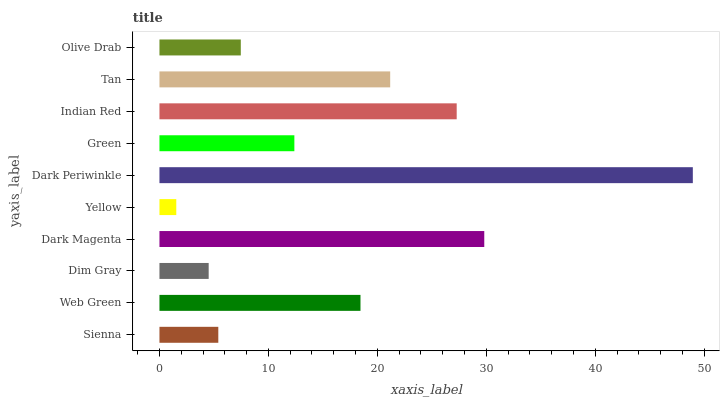Is Yellow the minimum?
Answer yes or no. Yes. Is Dark Periwinkle the maximum?
Answer yes or no. Yes. Is Web Green the minimum?
Answer yes or no. No. Is Web Green the maximum?
Answer yes or no. No. Is Web Green greater than Sienna?
Answer yes or no. Yes. Is Sienna less than Web Green?
Answer yes or no. Yes. Is Sienna greater than Web Green?
Answer yes or no. No. Is Web Green less than Sienna?
Answer yes or no. No. Is Web Green the high median?
Answer yes or no. Yes. Is Green the low median?
Answer yes or no. Yes. Is Dark Magenta the high median?
Answer yes or no. No. Is Tan the low median?
Answer yes or no. No. 